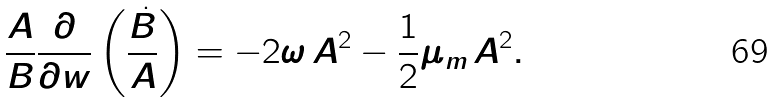<formula> <loc_0><loc_0><loc_500><loc_500>\frac { A } { B } \frac { \partial } { \partial w } \left ( \frac { \dot { B } } { A } \right ) = - 2 \omega \, A ^ { 2 } - { \frac { 1 } { 2 } } \mu _ { m } \, A ^ { 2 } .</formula> 